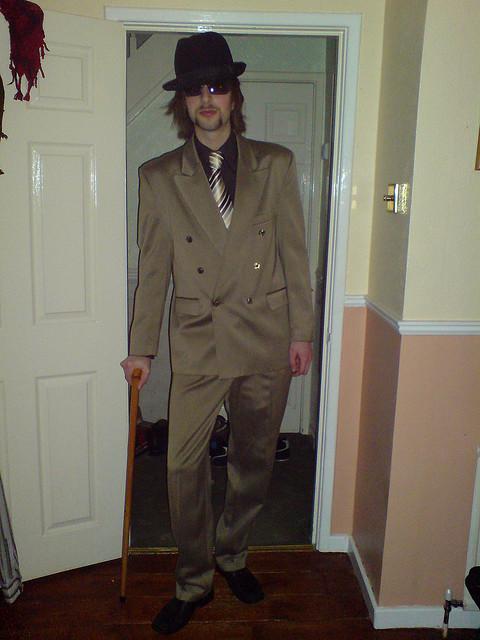How many men are in this photo?
Give a very brief answer. 1. 